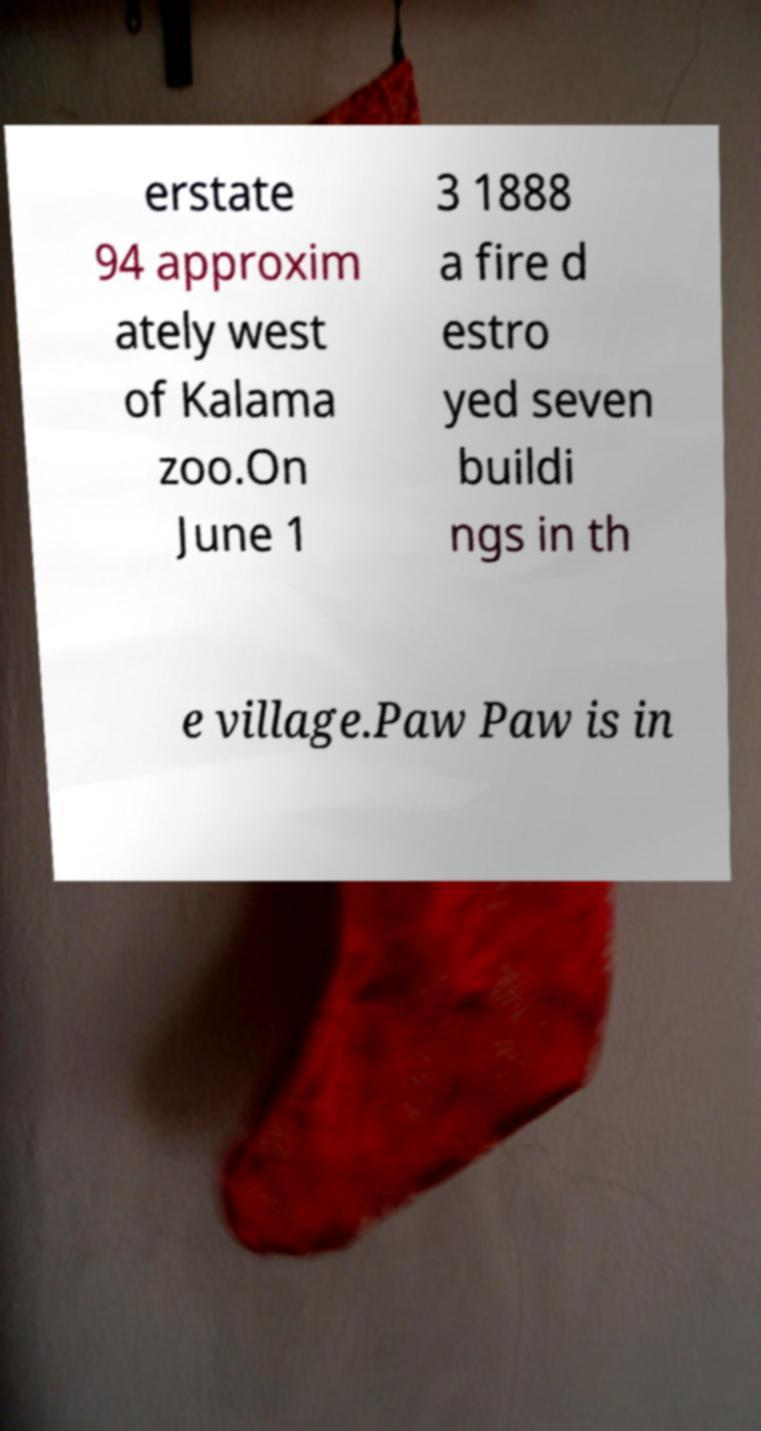Could you assist in decoding the text presented in this image and type it out clearly? erstate 94 approxim ately west of Kalama zoo.On June 1 3 1888 a fire d estro yed seven buildi ngs in th e village.Paw Paw is in 